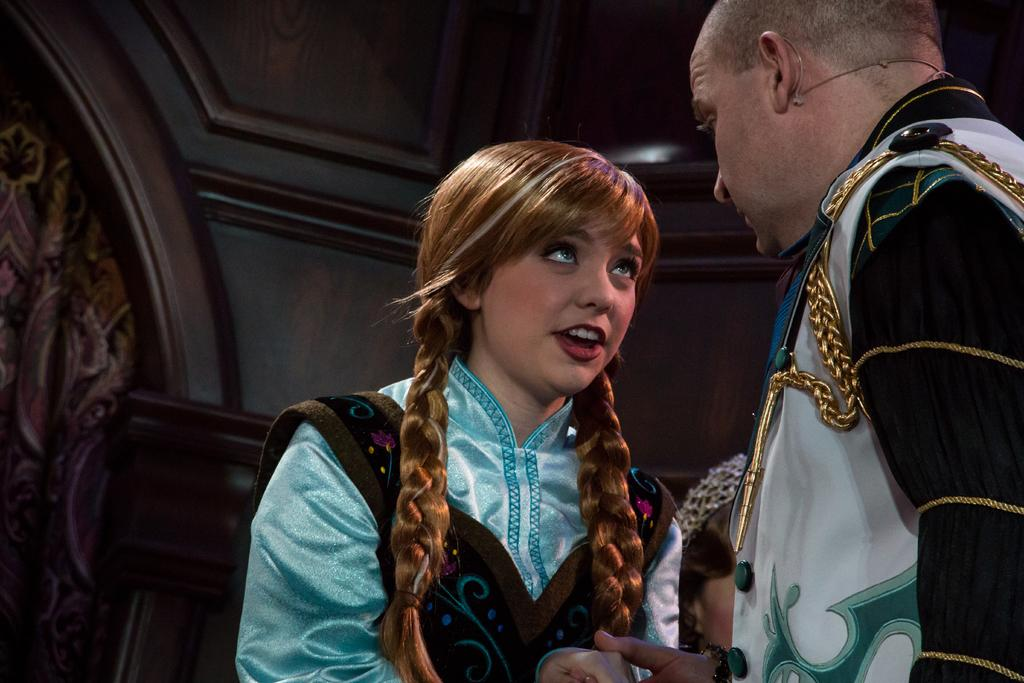Who are the people in the image? There is a man and a girl in the image. What can be seen in the background of the image? There is a building in the background of the image. What type of haircut is the building getting in the image? There is no haircut being given in the image, as the building is not a living being. 